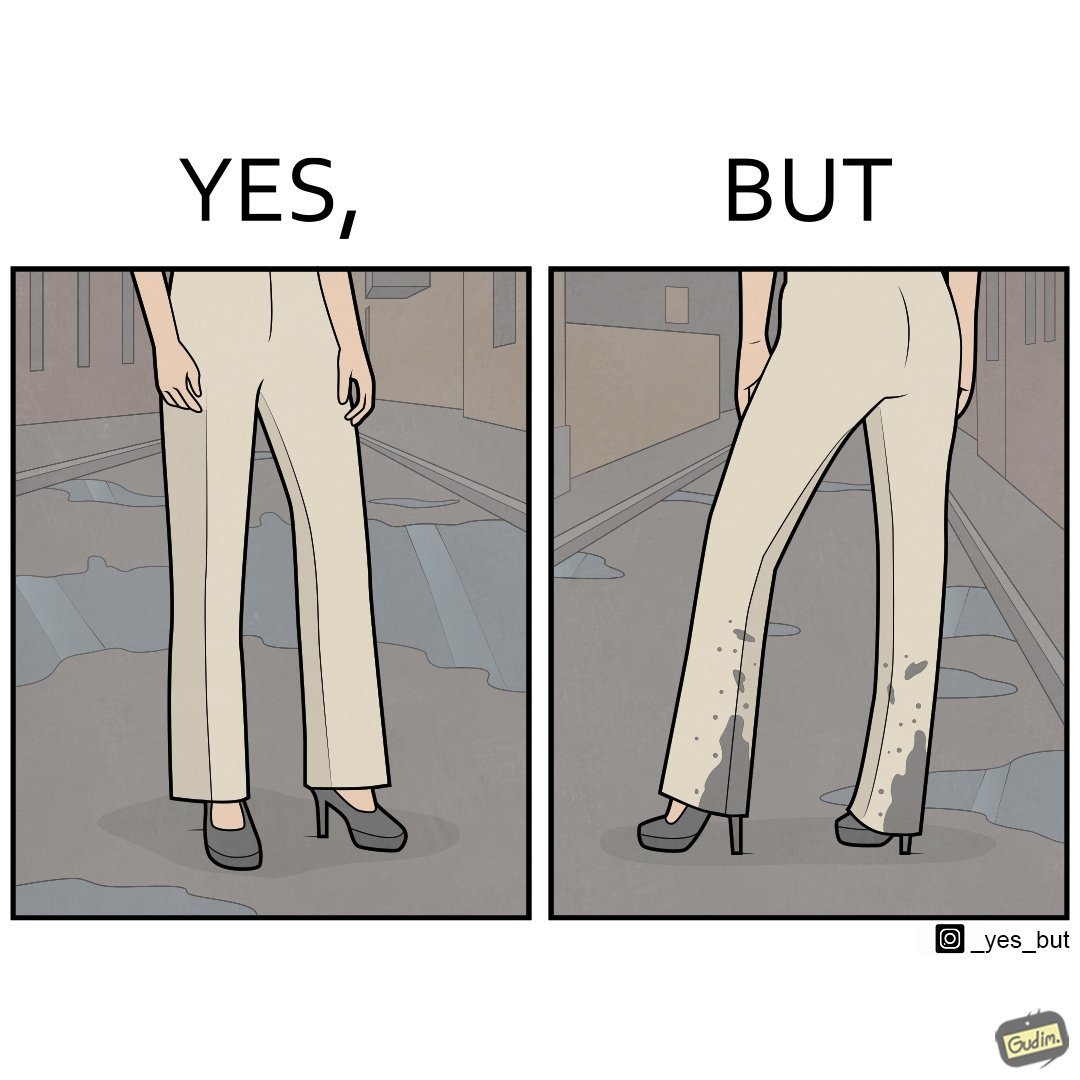What do you see in each half of this image? In the left part of the image: a person wearing white pants and high heels on a road filled with water. In the right part of the image: a person wearing white pants and high heels, but her pants are soaked in water when viewed from the back. 